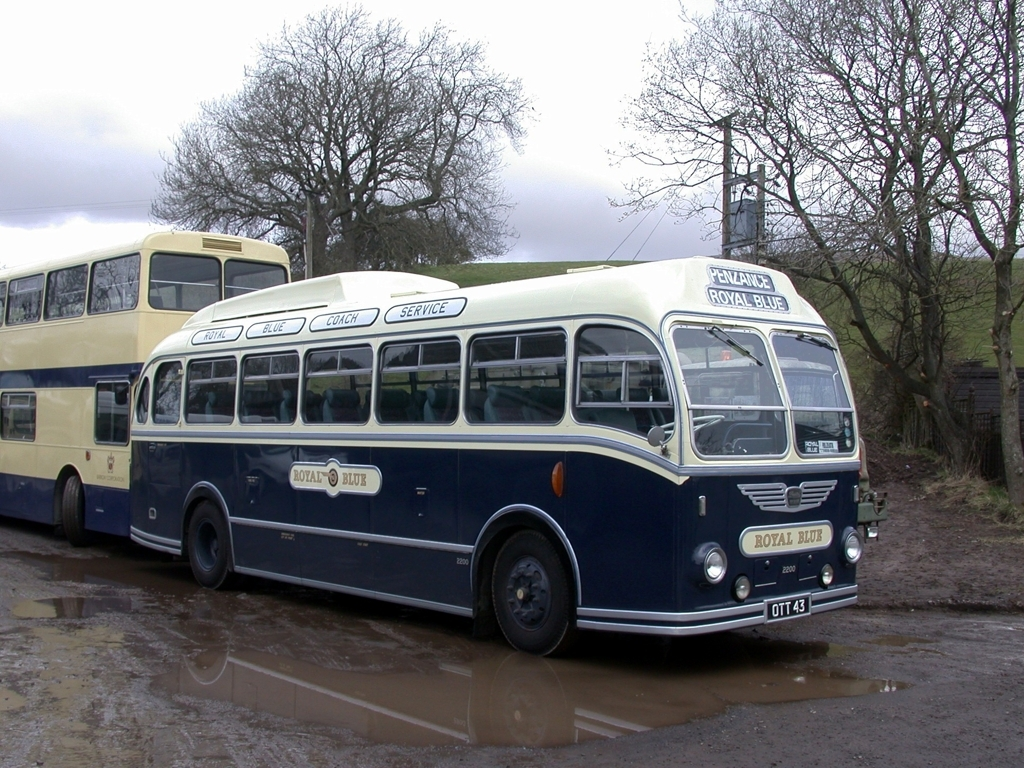Can you tell me more about the buses shown in the image? Certainly! The image showcases two vintage coaches, with the prominent one labeled 'Royal Blue.' They appear to be classic British buses, notable for their distinct curved design and two-tone color scheme. These buses are often associated with mid-20th-century public transportation. Their pristine condition suggests they might now be preserved for historical or display purposes, perhaps at a transport museum or a vintage vehicle rally. 